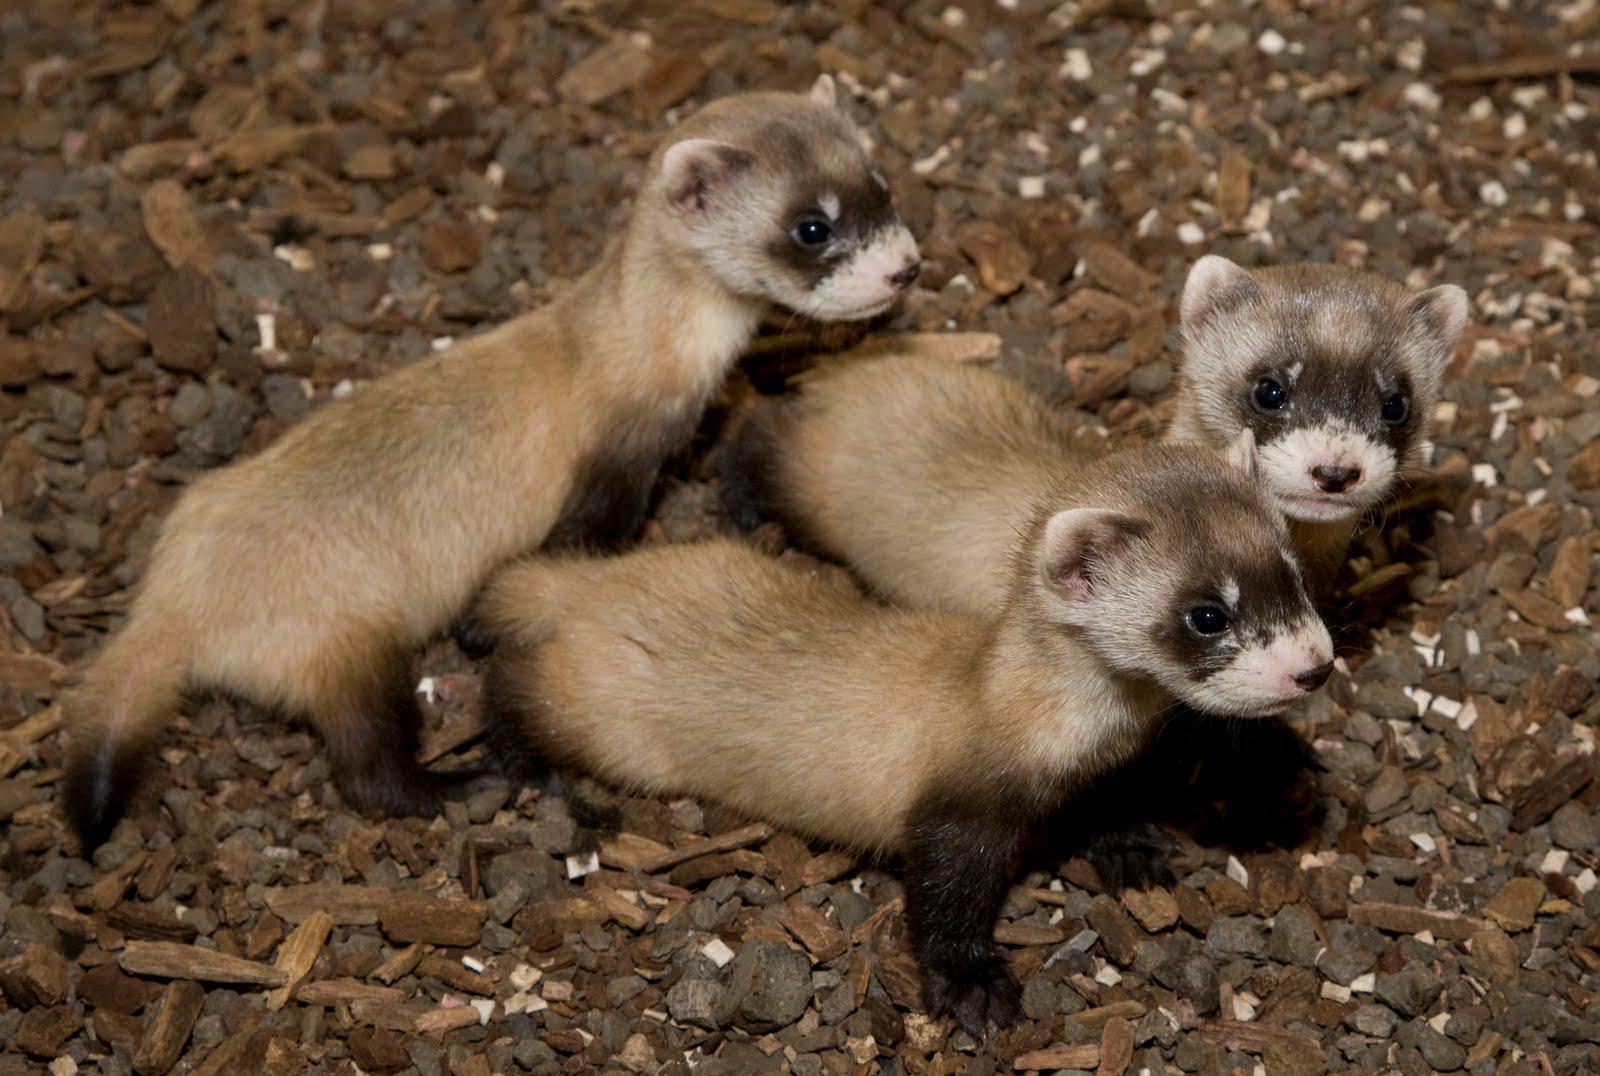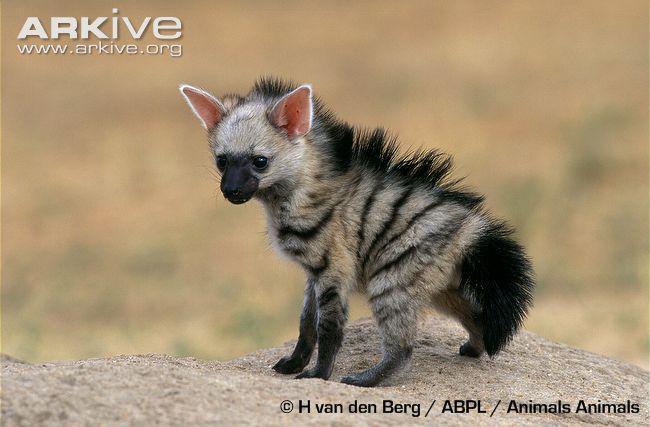The first image is the image on the left, the second image is the image on the right. Given the left and right images, does the statement "Each image contains the same number of animals." hold true? Answer yes or no. No. 